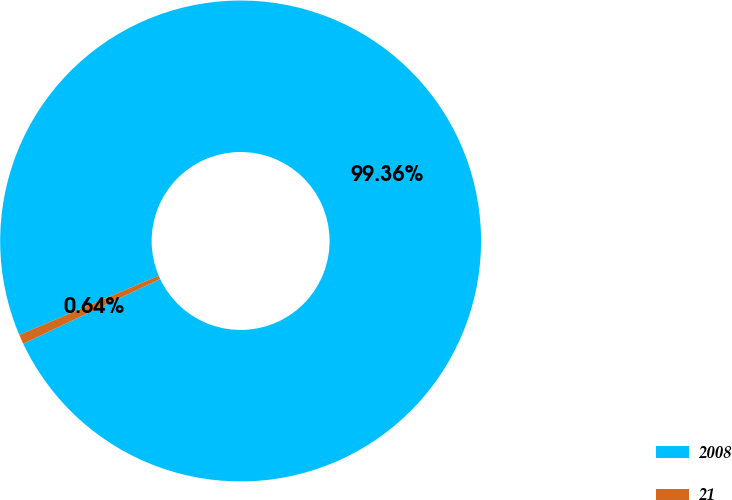Convert chart. <chart><loc_0><loc_0><loc_500><loc_500><pie_chart><fcel>2008<fcel>21<nl><fcel>99.36%<fcel>0.64%<nl></chart> 